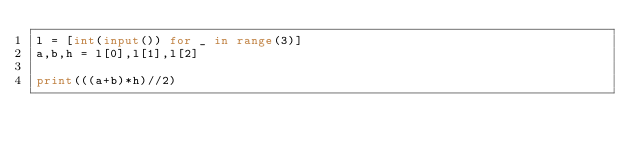Convert code to text. <code><loc_0><loc_0><loc_500><loc_500><_Python_>l = [int(input()) for _ in range(3)]
a,b,h = l[0],l[1],l[2]

print(((a+b)*h)//2)</code> 